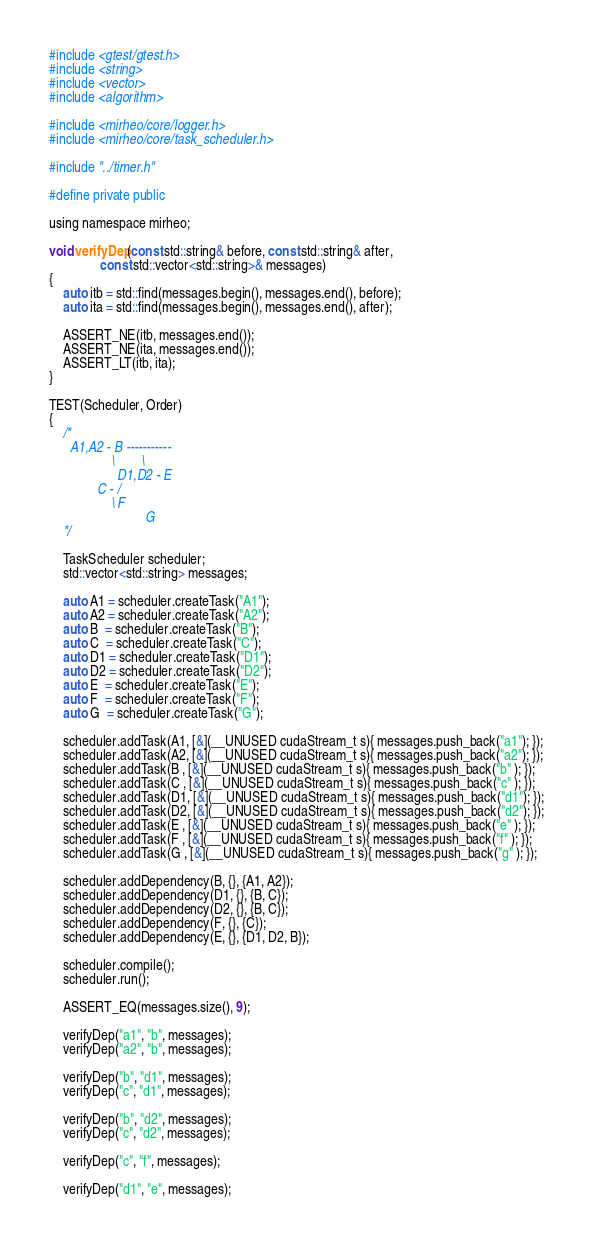Convert code to text. <code><loc_0><loc_0><loc_500><loc_500><_Cuda_>#include <gtest/gtest.h>
#include <string>
#include <vector>
#include <algorithm>

#include <mirheo/core/logger.h>
#include <mirheo/core/task_scheduler.h>

#include "../timer.h"

#define private public

using namespace mirheo;

void verifyDep(const std::string& before, const std::string& after,
               const std::vector<std::string>& messages)
{
    auto itb = std::find(messages.begin(), messages.end(), before);
    auto ita = std::find(messages.begin(), messages.end(), after);

    ASSERT_NE(itb, messages.end());
    ASSERT_NE(ita, messages.end());
    ASSERT_LT(itb, ita);
}

TEST(Scheduler, Order)
{
    /*
      A1,A2 - B -----------
                  \        \
                    D1,D2 - E
              C - /
                  \ F
                            G
    */
    
    TaskScheduler scheduler;
    std::vector<std::string> messages;

    auto A1 = scheduler.createTask("A1");
    auto A2 = scheduler.createTask("A2");
    auto B  = scheduler.createTask("B");
    auto C  = scheduler.createTask("C");
    auto D1 = scheduler.createTask("D1");
    auto D2 = scheduler.createTask("D2");
    auto E  = scheduler.createTask("E");
    auto F  = scheduler.createTask("F");
    auto G  = scheduler.createTask("G");

    scheduler.addTask(A1, [&](__UNUSED cudaStream_t s){ messages.push_back("a1"); });
    scheduler.addTask(A2, [&](__UNUSED cudaStream_t s){ messages.push_back("a2"); });
    scheduler.addTask(B , [&](__UNUSED cudaStream_t s){ messages.push_back("b" ); });
    scheduler.addTask(C , [&](__UNUSED cudaStream_t s){ messages.push_back("c" ); });
    scheduler.addTask(D1, [&](__UNUSED cudaStream_t s){ messages.push_back("d1"); });
    scheduler.addTask(D2, [&](__UNUSED cudaStream_t s){ messages.push_back("d2"); });
    scheduler.addTask(E , [&](__UNUSED cudaStream_t s){ messages.push_back("e" ); });
    scheduler.addTask(F , [&](__UNUSED cudaStream_t s){ messages.push_back("f" ); });
    scheduler.addTask(G , [&](__UNUSED cudaStream_t s){ messages.push_back("g" ); });
                
    scheduler.addDependency(B, {}, {A1, A2});
    scheduler.addDependency(D1, {}, {B, C});
    scheduler.addDependency(D2, {}, {B, C});
    scheduler.addDependency(F, {}, {C});
    scheduler.addDependency(E, {}, {D1, D2, B});

    scheduler.compile();
    scheduler.run();

    ASSERT_EQ(messages.size(), 9);

    verifyDep("a1", "b", messages);
    verifyDep("a2", "b", messages);

    verifyDep("b", "d1", messages);
    verifyDep("c", "d1", messages);

    verifyDep("b", "d2", messages);
    verifyDep("c", "d2", messages);

    verifyDep("c", "f", messages);

    verifyDep("d1", "e", messages);</code> 